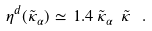<formula> <loc_0><loc_0><loc_500><loc_500>\eta ^ { d } ( \tilde { \kappa } _ { \alpha } ) \simeq \, 1 . 4 \, \tilde { \kappa } _ { \alpha } \ \tilde { \kappa } \, \ .</formula> 